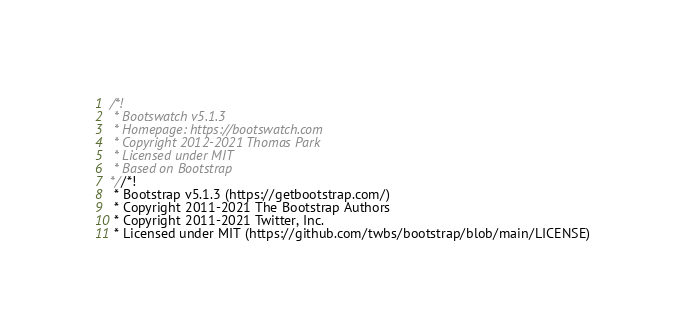Convert code to text. <code><loc_0><loc_0><loc_500><loc_500><_CSS_>/*!
 * Bootswatch v5.1.3
 * Homepage: https://bootswatch.com
 * Copyright 2012-2021 Thomas Park
 * Licensed under MIT
 * Based on Bootstrap
*//*!
 * Bootstrap v5.1.3 (https://getbootstrap.com/)
 * Copyright 2011-2021 The Bootstrap Authors
 * Copyright 2011-2021 Twitter, Inc.
 * Licensed under MIT (https://github.com/twbs/bootstrap/blob/main/LICENSE)</code> 